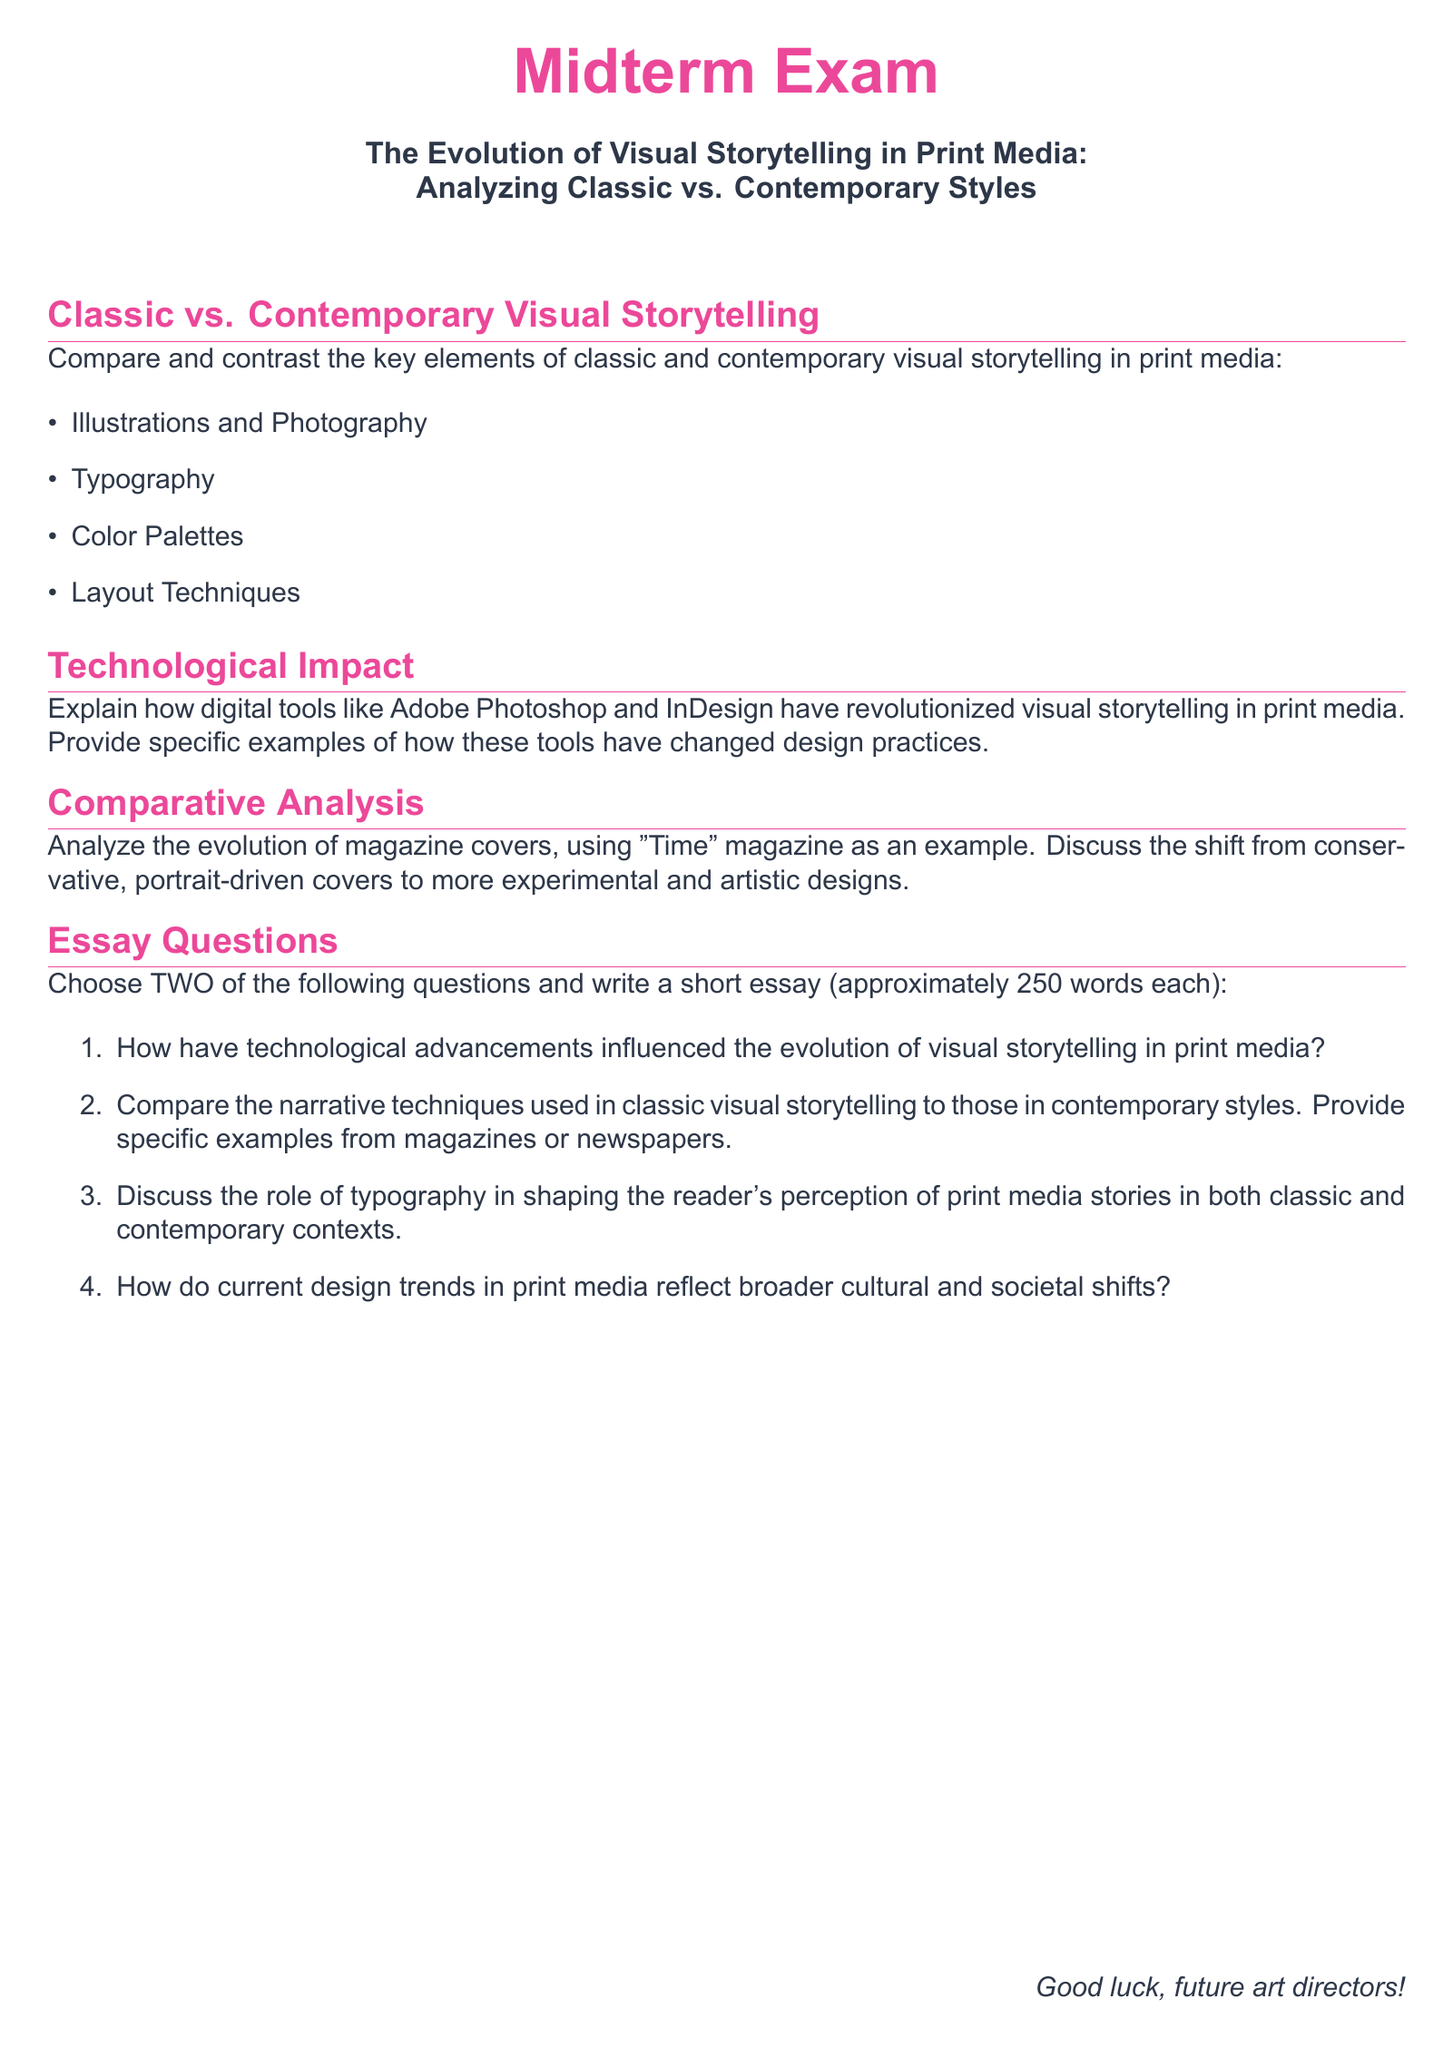What is the title of the exam? The title of the exam is presented prominently at the beginning of the document, which indicates the subject of the assessment.
Answer: The Evolution of Visual Storytelling in Print Media: Analyzing Classic vs. Contemporary Styles How many sections are there in the exam? The exam is divided into distinct sections, each focusing on different aspects of visual storytelling and design.
Answer: Four What is one of the techniques compared in classic vs. contemporary visual storytelling? The document lists various elements of visual storytelling that are compared, providing insight into design trends.
Answer: Typography What is the specific length requirement for the essay questions? The length requirement is specified in the essay section, guiding students on how detailed their responses should be.
Answer: Approximately 250 words each Which magazine is used as an example for comparative analysis? The document mentions a specific magazine that serves as an example for analyzing design evolution.
Answer: Time What type of tools are mentioned to have revolutionized visual storytelling? The document refers to specific modern technologies that have changed design practices in print media.
Answer: Digital tools What color is used for the section titles? The document specifies a color scheme for the section titles, contributing to the visual appeal of the exam.
Answer: Accent What is the sentiment expressed at the end of the document? The closing statement of the document aims to motivate and encourage the students as they prepare for the exam.
Answer: Good luck, future art directors! 